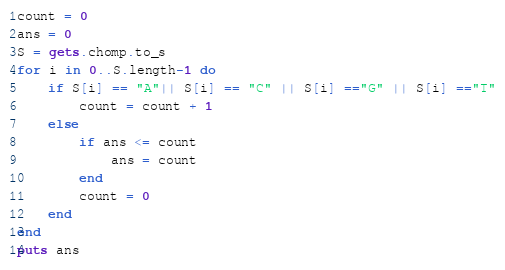Convert code to text. <code><loc_0><loc_0><loc_500><loc_500><_Ruby_>count = 0
ans = 0
S = gets.chomp.to_s
for i in 0..S.length-1 do
    if S[i] == "A"|| S[i] == "C" || S[i] =="G" || S[i] =="T"
        count = count + 1
    else
        if ans <= count
            ans = count
        end
        count = 0
    end
end
puts ans</code> 